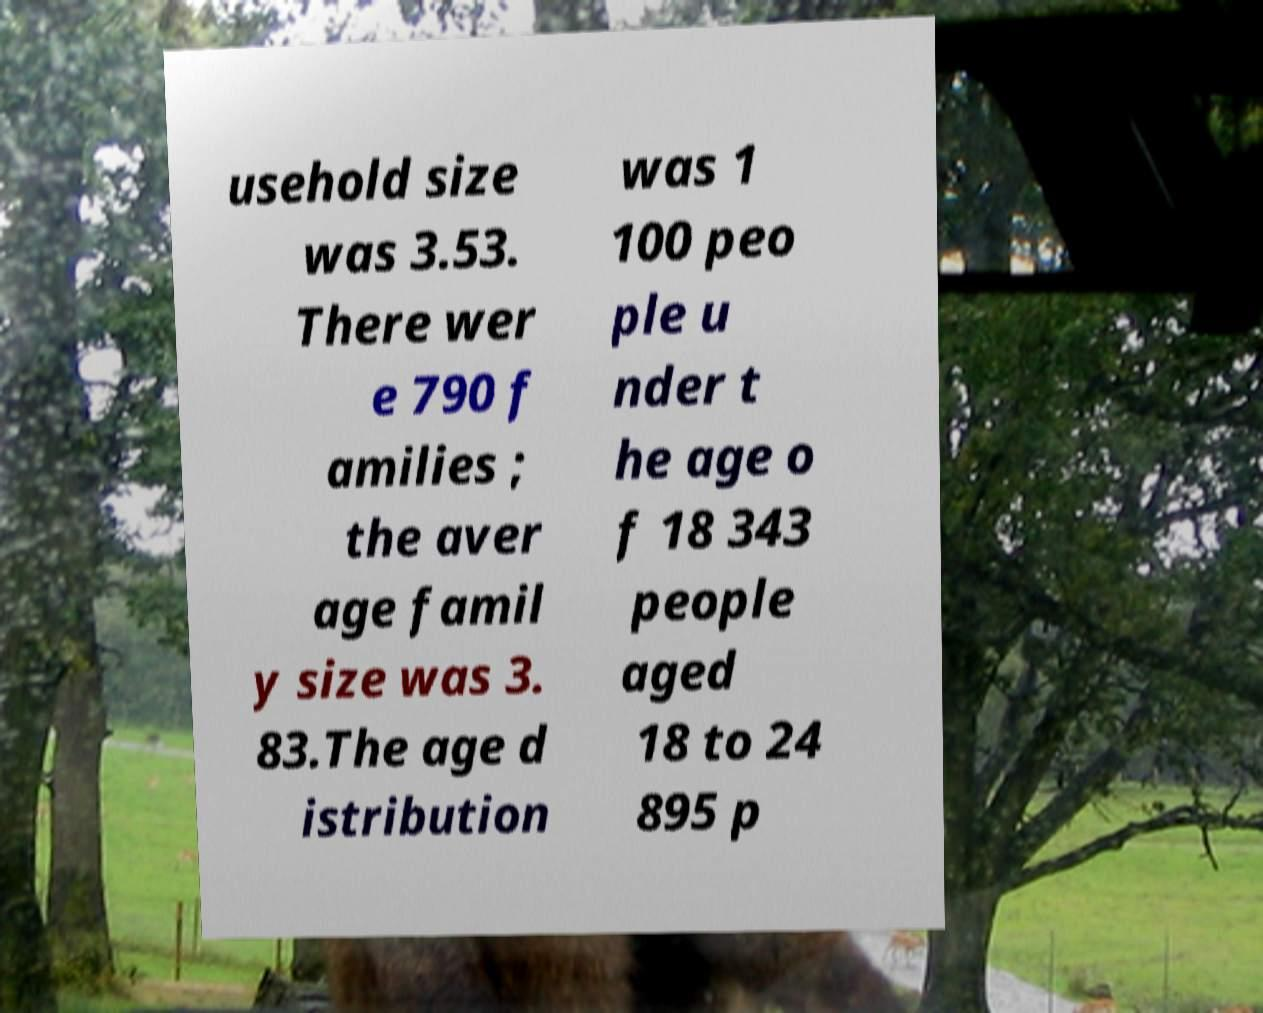Can you accurately transcribe the text from the provided image for me? usehold size was 3.53. There wer e 790 f amilies ; the aver age famil y size was 3. 83.The age d istribution was 1 100 peo ple u nder t he age o f 18 343 people aged 18 to 24 895 p 